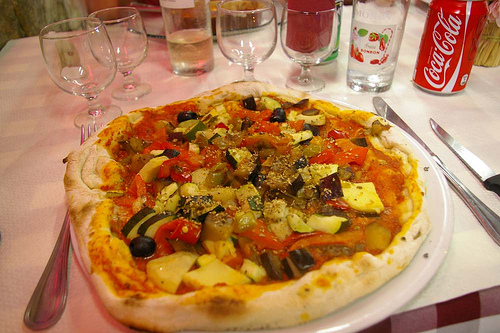Does the glass on the table look full? The glass on the table appears empty, perhaps awaiting a refill of a choice beverage to complement the meal. 